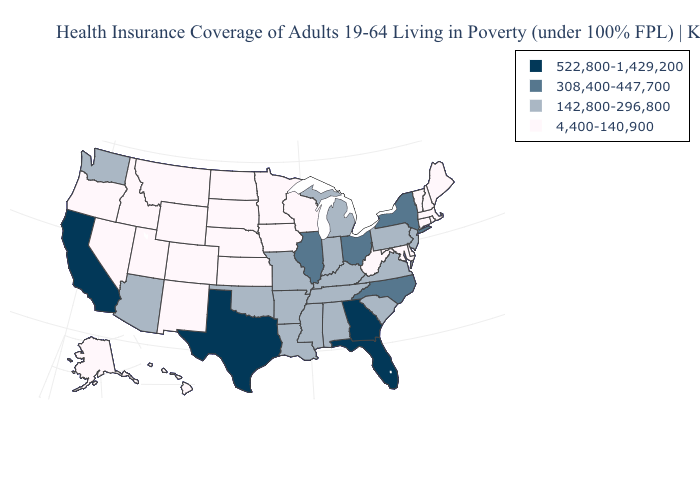What is the value of Vermont?
Be succinct. 4,400-140,900. Name the states that have a value in the range 308,400-447,700?
Quick response, please. Illinois, New York, North Carolina, Ohio. Among the states that border Utah , which have the lowest value?
Give a very brief answer. Colorado, Idaho, Nevada, New Mexico, Wyoming. Does Georgia have the highest value in the USA?
Quick response, please. Yes. What is the highest value in states that border South Dakota?
Concise answer only. 4,400-140,900. Name the states that have a value in the range 522,800-1,429,200?
Give a very brief answer. California, Florida, Georgia, Texas. What is the lowest value in the USA?
Quick response, please. 4,400-140,900. Does Illinois have the same value as New Jersey?
Concise answer only. No. Does Utah have the lowest value in the West?
Concise answer only. Yes. Does California have the highest value in the USA?
Keep it brief. Yes. How many symbols are there in the legend?
Answer briefly. 4. What is the value of Montana?
Write a very short answer. 4,400-140,900. Which states have the lowest value in the USA?
Answer briefly. Alaska, Colorado, Connecticut, Delaware, Hawaii, Idaho, Iowa, Kansas, Maine, Maryland, Massachusetts, Minnesota, Montana, Nebraska, Nevada, New Hampshire, New Mexico, North Dakota, Oregon, Rhode Island, South Dakota, Utah, Vermont, West Virginia, Wisconsin, Wyoming. What is the lowest value in the Northeast?
Be succinct. 4,400-140,900. 